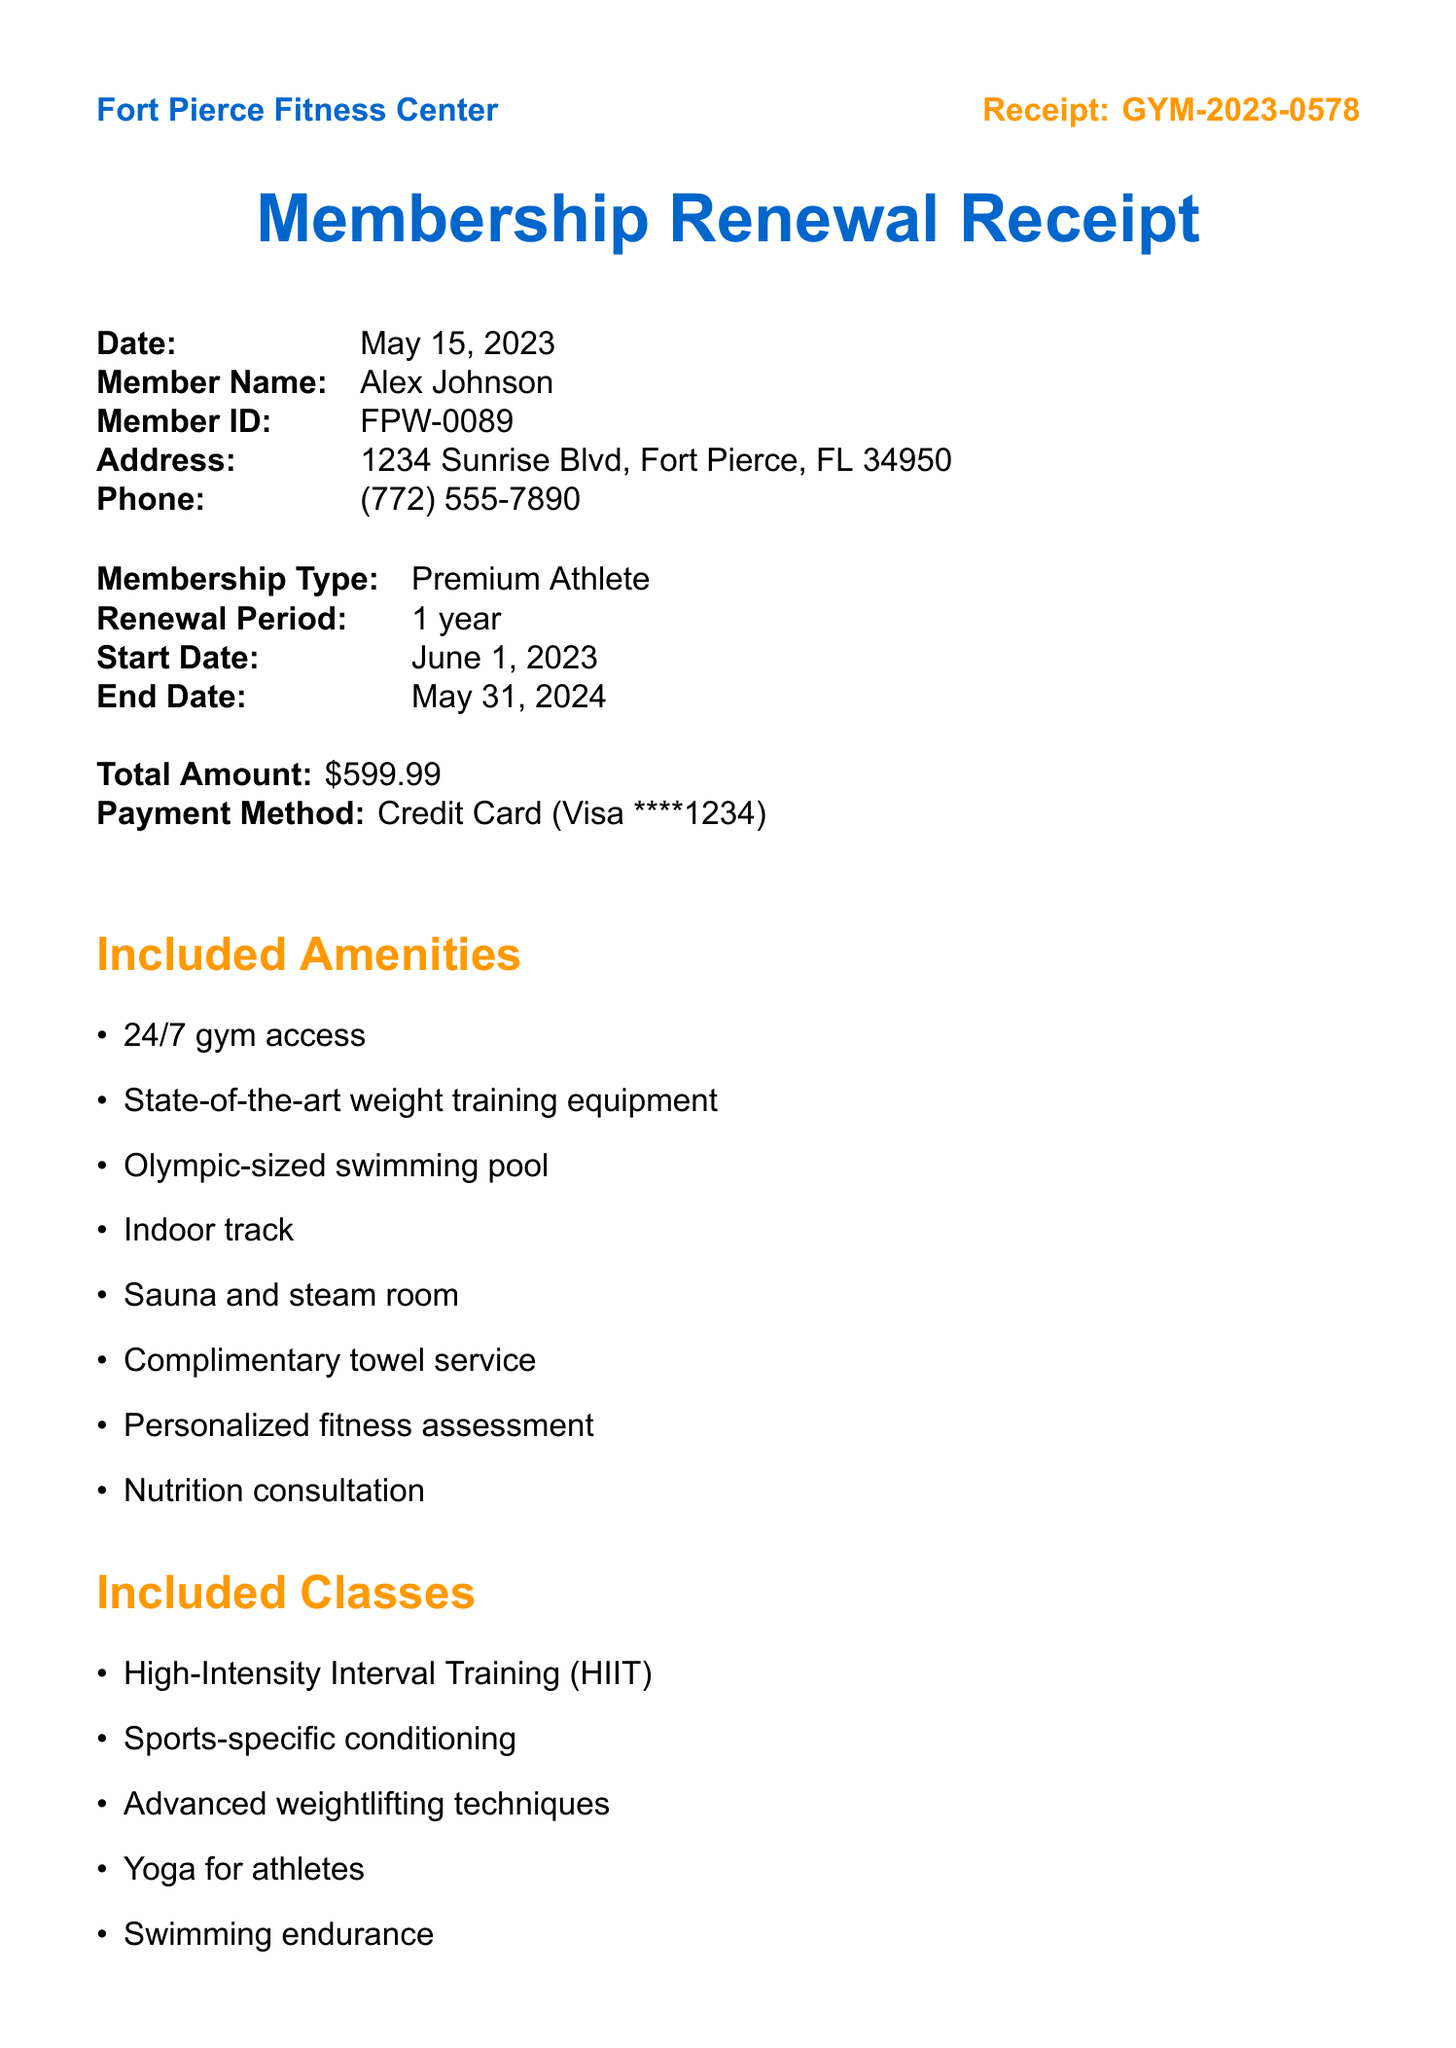What is the membership type? The membership type is specified in the document under "Membership Type."
Answer: Premium Athlete When does the membership start? The membership start date is mentioned in the renewal section of the document.
Answer: June 1, 2023 What is the total amount for the renewal? The total amount is clearly stated in the document as the cost for the membership renewal.
Answer: $599.99 What amenities include sauna and steam room? The amenities listed in the document specifically mention the sauna and steam room.
Answer: Sauna and steam room How many guest passes are complimentary per year? The document specifies how many guest passes are included per year under special features.
Answer: 4 per year What classes focus on athletic recovery? The classes listed in the document include one that is aimed at aiding recovery for athletes.
Answer: Athletic recovery and stretching What does the staff note say? The staff note contains a personalized welcome message for the member reflecting their background.
Answer: Welcome back, Alex! As a former Fort Pierce Westwood Academy state champion, we're excited to continue supporting your fitness journey. Don't forget to check out our new sports-specific training programs! What is the phone number for the gym? The phone number is provided in the contact information section of the document.
Answer: (772) 555-7890 What is the address of the Fort Pierce Fitness Center? The address is listed in the document under the gym information section.
Answer: 1234 Sunrise Blvd, Fort Pierce, FL 34950 